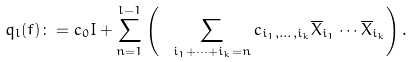Convert formula to latex. <formula><loc_0><loc_0><loc_500><loc_500>q _ { l } ( f ) \colon = c _ { 0 } I + \sum _ { n = 1 } ^ { l - 1 } \left ( \ \, \sum _ { i _ { 1 } + \cdots + i _ { k } = n } c _ { i _ { 1 } , \dots , i _ { k } } \overline { X } _ { i _ { 1 } } \cdots \overline { X } _ { i _ { k } } \right ) .</formula> 